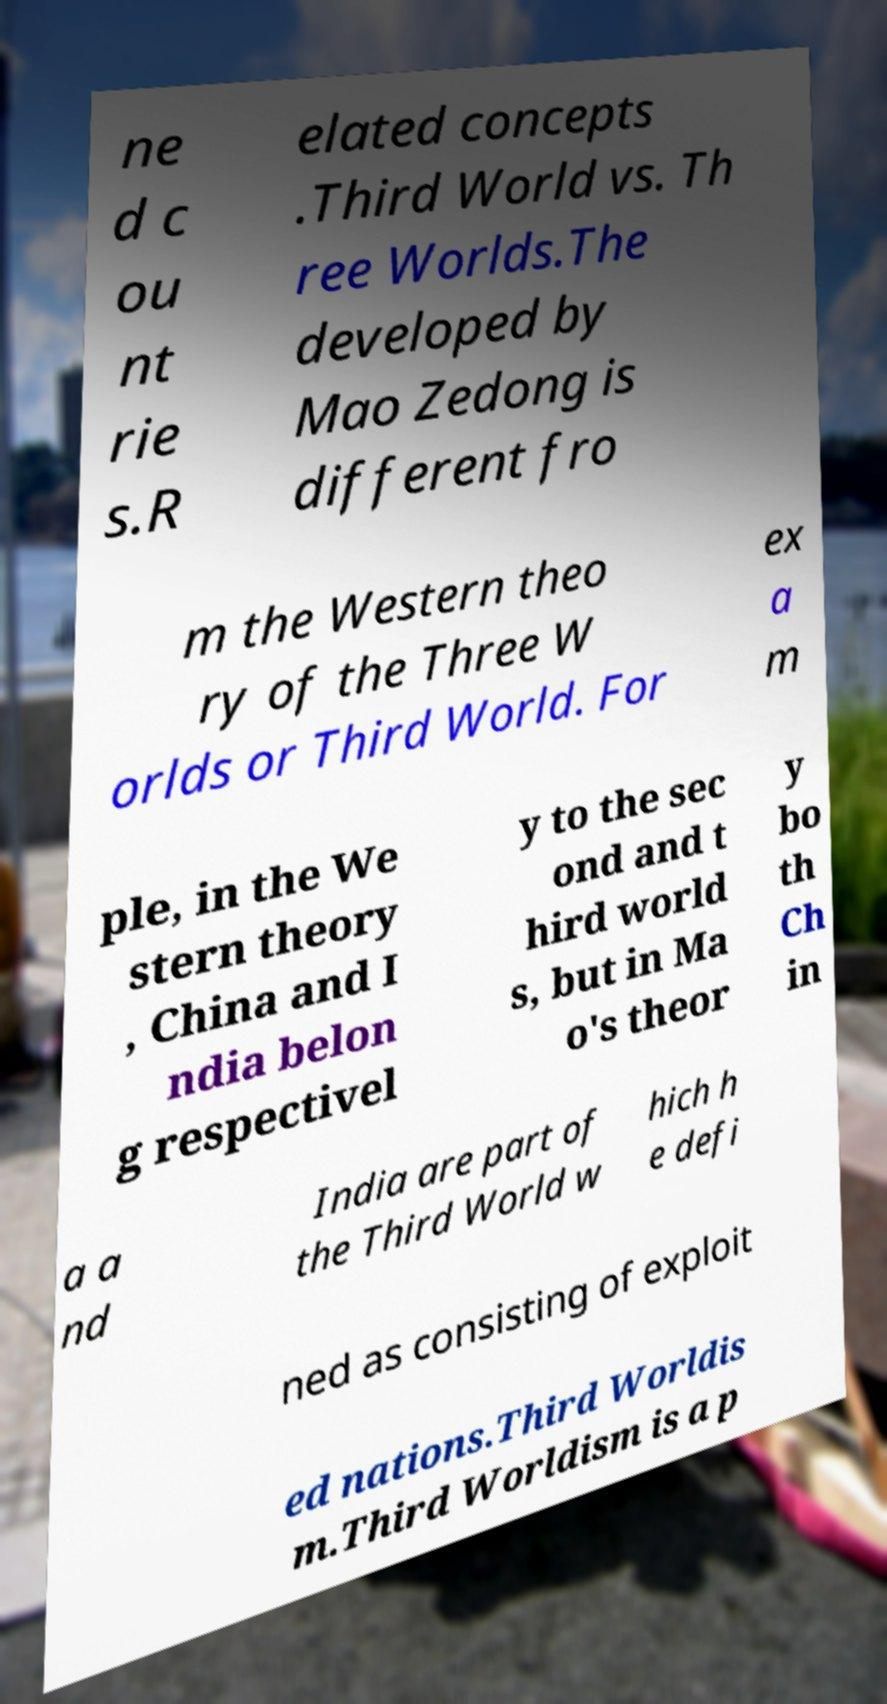Can you read and provide the text displayed in the image?This photo seems to have some interesting text. Can you extract and type it out for me? ne d c ou nt rie s.R elated concepts .Third World vs. Th ree Worlds.The developed by Mao Zedong is different fro m the Western theo ry of the Three W orlds or Third World. For ex a m ple, in the We stern theory , China and I ndia belon g respectivel y to the sec ond and t hird world s, but in Ma o's theor y bo th Ch in a a nd India are part of the Third World w hich h e defi ned as consisting of exploit ed nations.Third Worldis m.Third Worldism is a p 